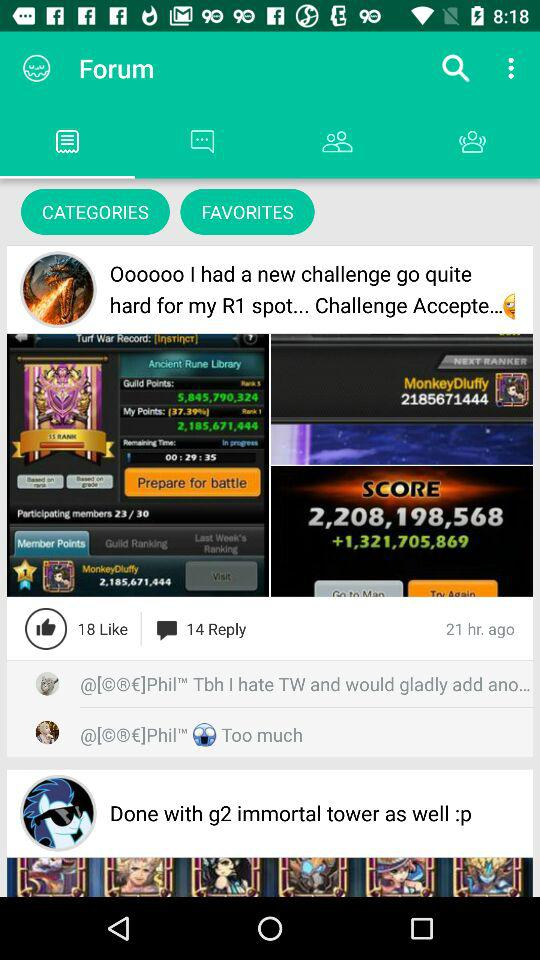How many hours ago was "Oooooo I had a new challenge go quite hard for my R1 spot... Challenge Accepte..." posted? "Oooooo I had a new challenge go quite hard for my R1 spot... Challenge Accepte..." was posted 21 hours ago. 